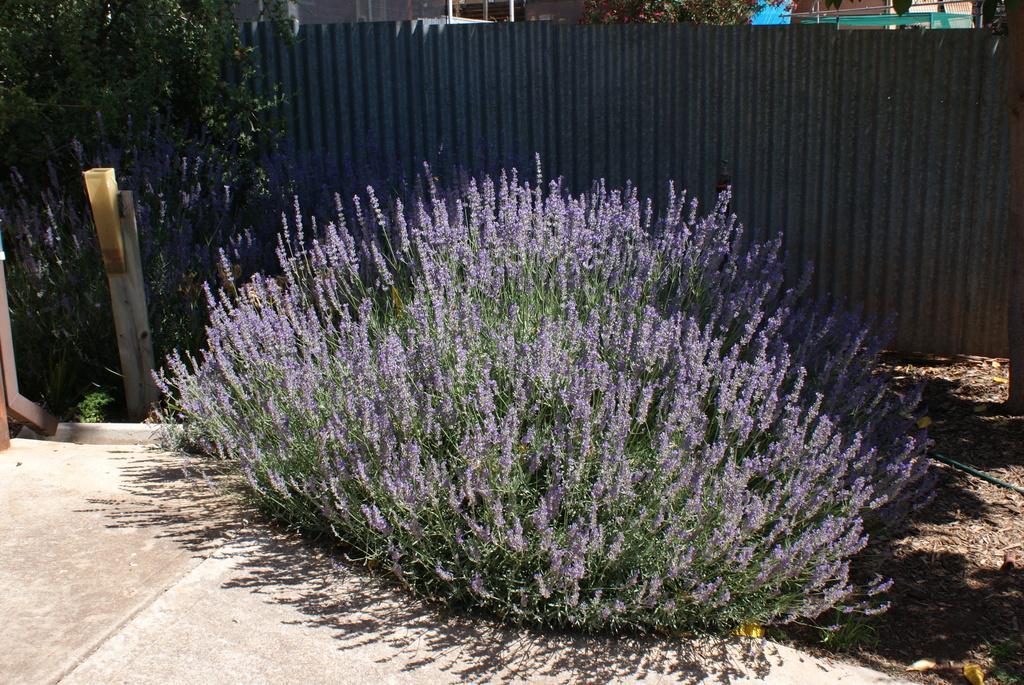In one or two sentences, can you explain what this image depicts? This picture shows a plant with flowers and we see a tree on the side and a metal fence and we see couple of buildings 